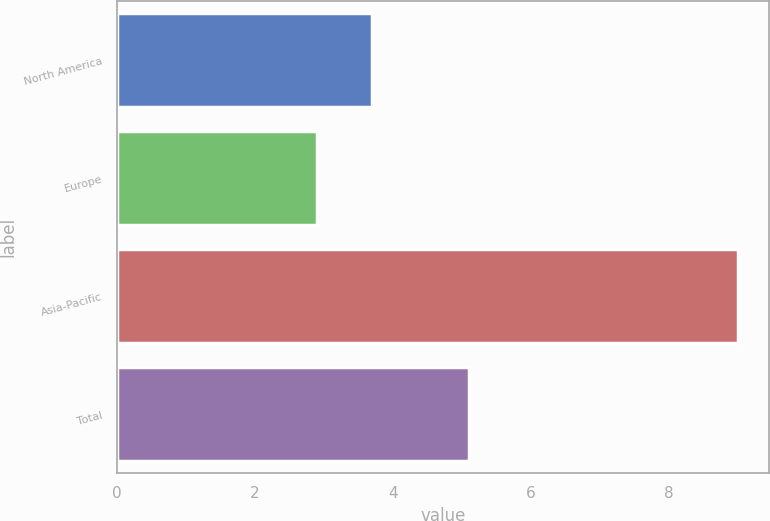Convert chart. <chart><loc_0><loc_0><loc_500><loc_500><bar_chart><fcel>North America<fcel>Europe<fcel>Asia-Pacific<fcel>Total<nl><fcel>3.7<fcel>2.9<fcel>9<fcel>5.1<nl></chart> 